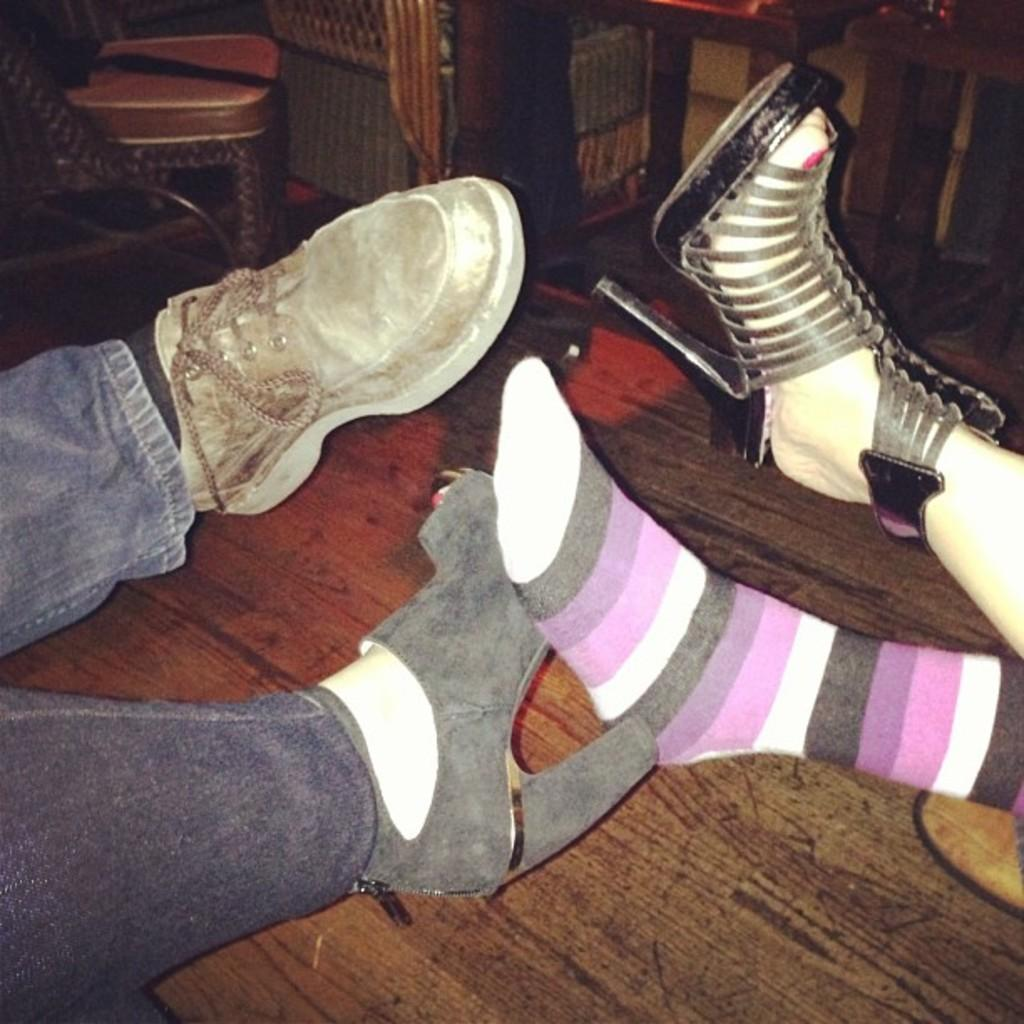What body parts are visible in the image? There are legs of persons in the image. What type of footwear can be seen in the image? There are shoes in the image. What type of clothing is worn on the feet in the image? There are socks in the image. What part of the shoes is visible in the image? There are heels in the image. What type of furniture is present in the image? There is a chair in the image. What type of surface is visible in the image? There is a floor in the image. What type of object is used for sitting in the image? The chair is used for sitting in the image. What type of object is used for placing items in the image? The table is used for placing items in the image. Where is the lamp located in the image? There is no lamp present in the image. What type of power source is used by the persons in the image? The provided facts do not mention any power source used by the persons in the image. 